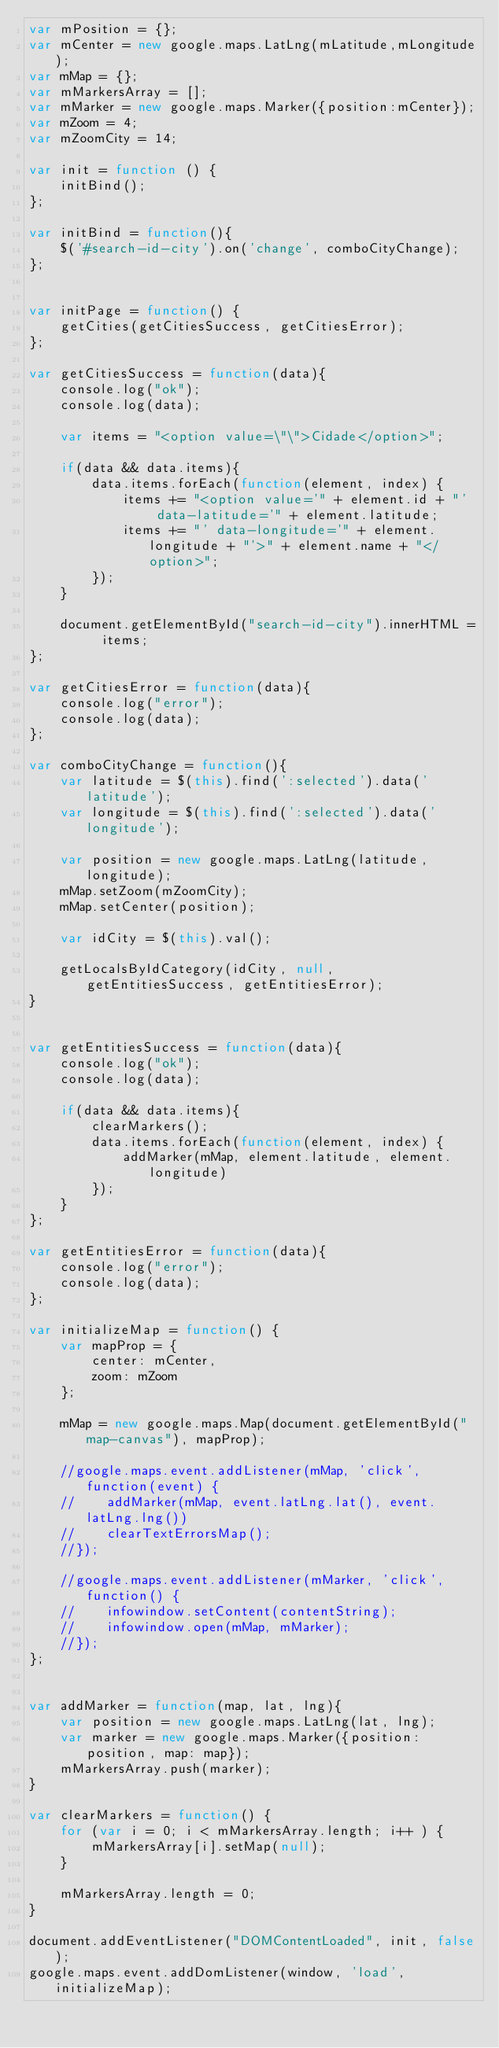<code> <loc_0><loc_0><loc_500><loc_500><_JavaScript_>var mPosition = {};
var mCenter = new google.maps.LatLng(mLatitude,mLongitude);
var mMap = {};
var mMarkersArray = [];
var mMarker = new google.maps.Marker({position:mCenter});
var mZoom = 4;
var mZoomCity = 14;

var init = function () {
	initBind();
};

var initBind = function(){
    $('#search-id-city').on('change', comboCityChange);
};


var initPage = function() {
    getCities(getCitiesSuccess, getCitiesError);
};

var getCitiesSuccess = function(data){
    console.log("ok");
    console.log(data);

    var items = "<option value=\"\">Cidade</option>";

    if(data && data.items){
        data.items.forEach(function(element, index) {
            items += "<option value='" + element.id + "'  data-latitude='" + element.latitude;
            items += "' data-longitude='" + element.longitude + "'>" + element.name + "</option>";
        });
    }

    document.getElementById("search-id-city").innerHTML =  items;
};

var getCitiesError = function(data){
    console.log("error");
    console.log(data);
};

var comboCityChange = function(){
    var latitude = $(this).find(':selected').data('latitude');
    var longitude = $(this).find(':selected').data('longitude');

    var position = new google.maps.LatLng(latitude,longitude);
    mMap.setZoom(mZoomCity);
    mMap.setCenter(position);

    var idCity = $(this).val();

    getLocalsByIdCategory(idCity, null, getEntitiesSuccess, getEntitiesError);
}


var getEntitiesSuccess = function(data){
    console.log("ok");
    console.log(data);

    if(data && data.items){
        clearMarkers();
        data.items.forEach(function(element, index) {
            addMarker(mMap, element.latitude, element.longitude)
        });
    }
};

var getEntitiesError = function(data){
    console.log("error");
    console.log(data);
};

var initializeMap = function() {
    var mapProp = {
        center: mCenter,
        zoom: mZoom
    };

    mMap = new google.maps.Map(document.getElementById("map-canvas"), mapProp);

    //google.maps.event.addListener(mMap, 'click', function(event) {
    //    addMarker(mMap, event.latLng.lat(), event.latLng.lng())
    //    clearTextErrorsMap();
    //});

    //google.maps.event.addListener(mMarker, 'click', function() {
    //    infowindow.setContent(contentString);
    //    infowindow.open(mMap, mMarker);
    //});
};


var addMarker = function(map, lat, lng){
    var position = new google.maps.LatLng(lat, lng);
    var marker = new google.maps.Marker({position: position, map: map});
    mMarkersArray.push(marker);
}

var clearMarkers = function() {
    for (var i = 0; i < mMarkersArray.length; i++ ) {
        mMarkersArray[i].setMap(null);
    }

    mMarkersArray.length = 0;
}

document.addEventListener("DOMContentLoaded", init, false);
google.maps.event.addDomListener(window, 'load', initializeMap);</code> 